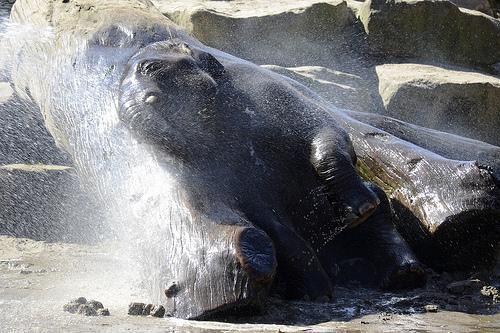How many elephants are in the water?
Give a very brief answer. 1. 